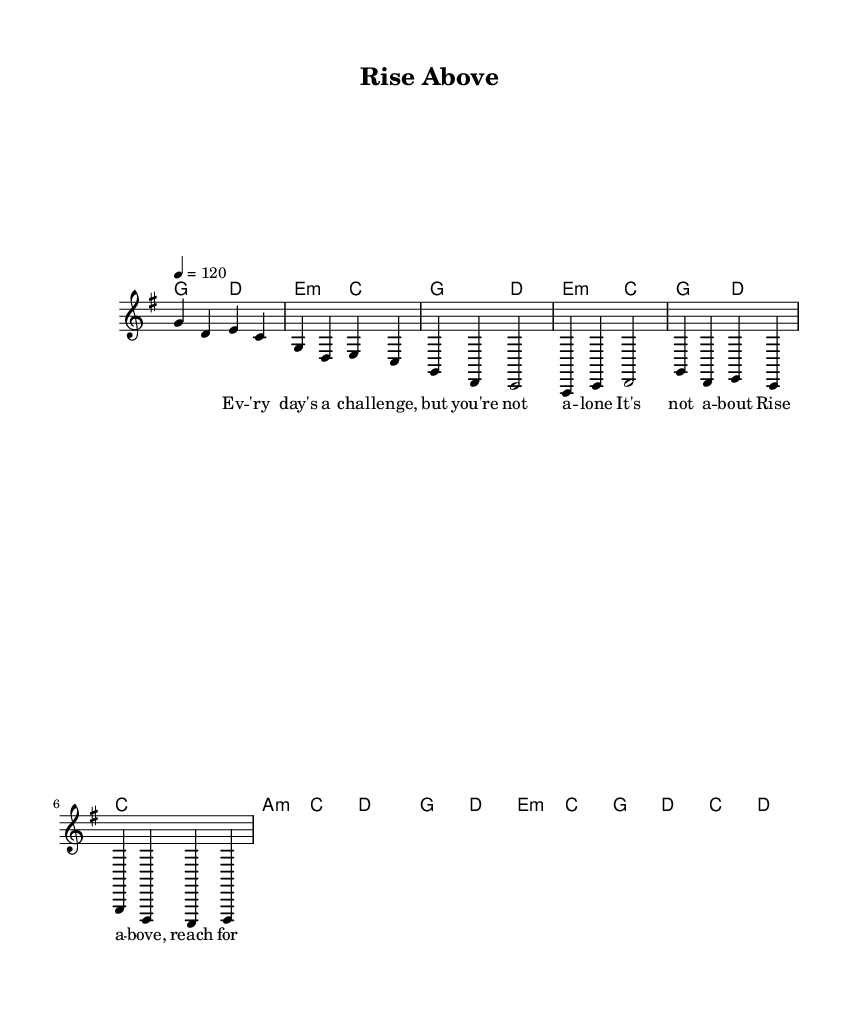What is the key signature of this music? The key signature is G major, which has one sharp (F#). This can be identified from the global section of the code, which states \key g \major.
Answer: G major What is the time signature of the piece? The time signature is 4/4, as indicated in the global section of the code with \time 4/4. This means there are four beats in each measure.
Answer: 4/4 What is the tempo marking of this music? The tempo marking is 120 beats per minute, specified in the global section with \tempo 4 = 120. This indicates the speed at which the piece should be played.
Answer: 120 What is the chord used in the pre-chorus? The chord used in the pre-chorus is A minor, indicated by the chord mode line a2:m c2 in the harmonies section. This shows the specific chord being played during this section of the song.
Answer: A minor In what section does the lyric line "Rise above, reach for the sky" appear? This lyric line appears in the chorus part, identified in the melody and lyrics under the section labeled as Chorus (partial). This is a pivotal moment in the song, emphasizing the theme of rising above challenges.
Answer: Chorus 